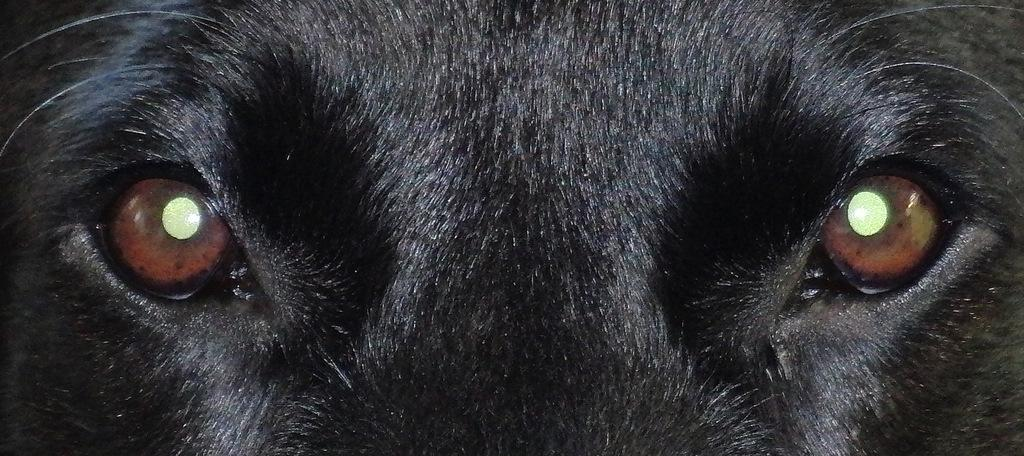What type of animal eyes are visible in the image? The image contains the eyes of an animal. What type of fiction is the animal reading in the image? There is no indication in the image that the animal is reading any fiction, as the image only contains the eyes of an animal. 